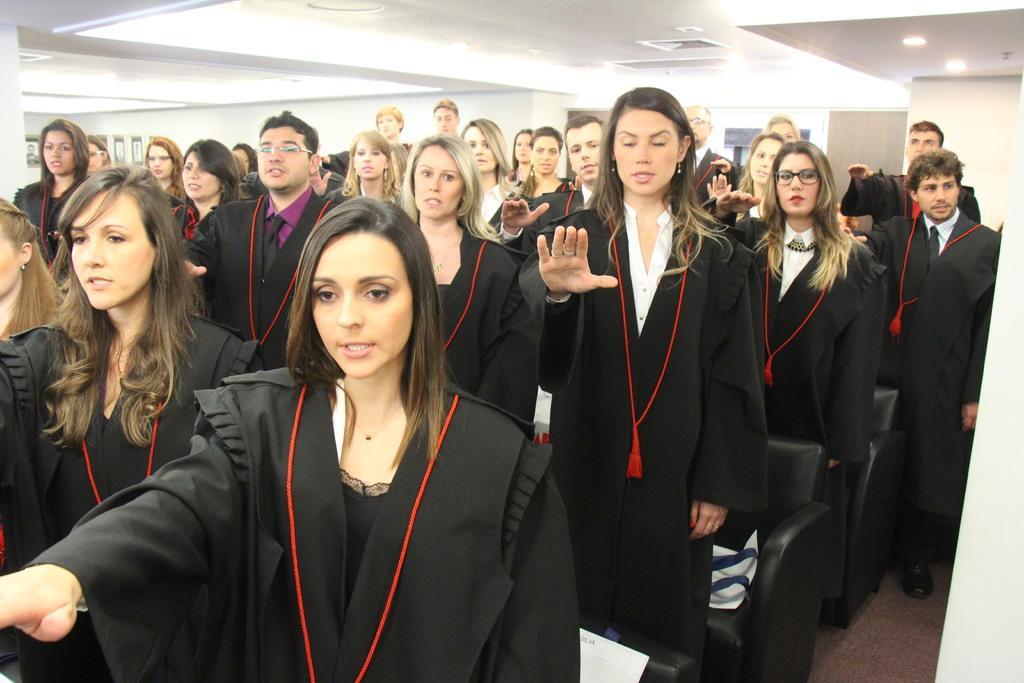In one or two sentences, can you explain what this image depicts? In the picture we can see many men and women are standing and taking an oath raising their hands and they are in black dresses and behind them, we can see chairs which are black in color and to the ceiling we can see some lights. 